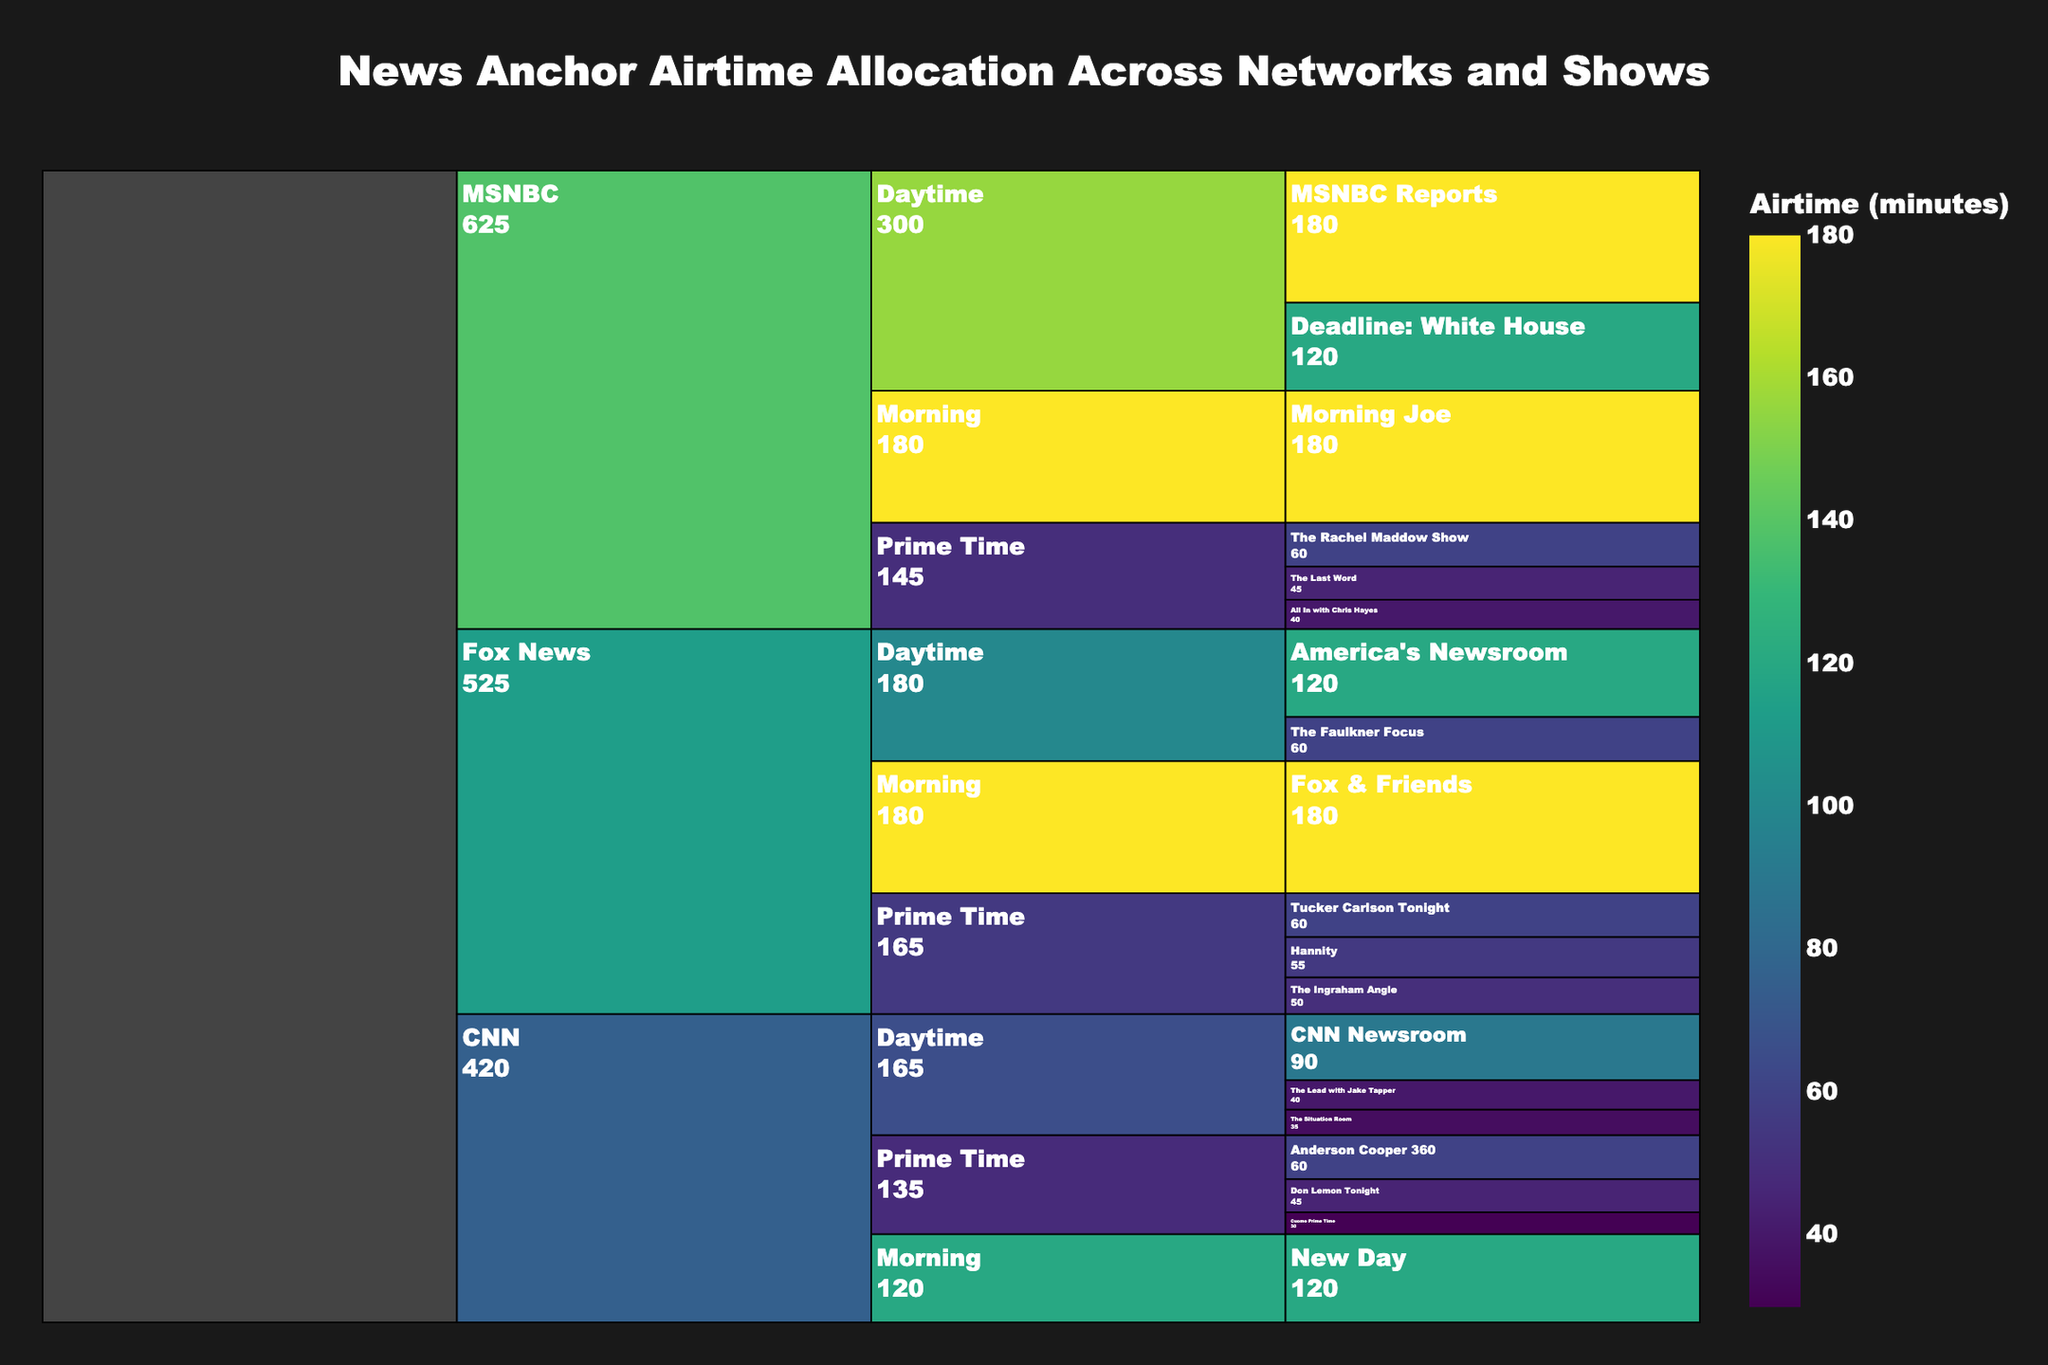what is the total airtime allocated to all Prime Time shows across all networks? Sum all airtime values for Prime Time shows: Anderson Cooper 360 (60), Don Lemon Tonight (45), Cuomo Prime Time (30), Tucker Carlson Tonight (60), Hannity (55), The Ingraham Angle (50), The Rachel Maddow Show (60), The Last Word (45), All In with Chris Hayes (40). Therefore, 60 + 45 + 30 + 60 + 55 + 50 + 60 + 45 + 40 = 445 minutes.
Answer: 445 minutes which network allocates the most airtime to Morning shows? Compare the airtime values for Morning shows for each network: CNN (New Day - 120), Fox News (Fox & Friends - 180), MSNBC (Morning Joe - 180). Both Fox News and MSNBC allocate 180 minutes.
Answer: Fox News and MSNBC how does the airtime of "Fox & Friends" compare to the total airtime of CNN’s Prime Time shows? Compare the airtime of "Fox & Friends" (180 minutes) to the sum of CNN’s Prime Time shows: Anderson Cooper 360 (60), Don Lemon Tonight (45), Cuomo Prime Time (30). Therefore, 60 + 45 + 30 = 135. Fox & Friends (180) has more airtime than CNN’s Prime Time total (135).
Answer: Fox & Friends has more airtime what is the difference in airtime between MSNBC's "Morning Joe" and CNN's "New Day"? Subtract the airtime of CNN's New Day (120) from MSNBC's Morning Joe (180). Therefore, 180 - 120 = 60 minutes.
Answer: 60 minutes which network has the least total airtime allocated to Daytime shows? Sum the airtime for Daytime shows for each network: CNN: The Lead with Jake Tapper (40), The Situation Room (35), CNN Newsroom (90); total = 40 + 35 + 90 = 165 minutes. Fox News: America’s Newsroom (120), The Faulkner Focus (60); total = 120 + 60 = 180 minutes. MSNBC: MSNBC Reports (180), Deadline: White House (120); total = 180 + 120 = 300 minutes. CNN has the least with 165 minutes.
Answer: CNN which show has the most airtime in Prime Time across all networks? Identify the show in Prime Time with the highest airtime value from the dataset. Tucker Carlson Tonight (60 minutes), Anderson Cooper 360 (60 minutes), and The Rachel Maddow Show (60 minutes) have equal airtime.
Answer: Tucker Carlson Tonight, Anderson Cooper 360, and The Rachel Maddow Show what is the average airtime of all Fox News shows? Sum the airtime values for all Fox News shows: Tucker Carlson Tonight (60), Hannity (55), The Ingraham Angle (50), America’s Newsroom (120), The Faulkner Focus (60), Fox & Friends (180). Total is 60 + 55 + 50 + 120 + 60 + 180 = 525 minutes. There are 6 shows, so the average is 525 / 6 = 87.5 minutes.
Answer: 87.5 minutes what percentage of total airtime is allocated to MSNBC's Daytime shows? Sum the airtime values for all shows to find the total airtime: 60 + 45 + 30 + 40 + 35 + 90 + 120 + 60 + 55 + 50 + 120 + 60 + 180 + 60 + 45 + 40 + 180 + 120 + 180 = 1695 minutes. The airtime for MSNBC Daytime shows is: MSNBC Reports (180), Deadline: White House (120), total = 180 + 120 = 300 minutes. The percentage is (300 / 1695) * 100 = 17.7%.
Answer: 17.7% 